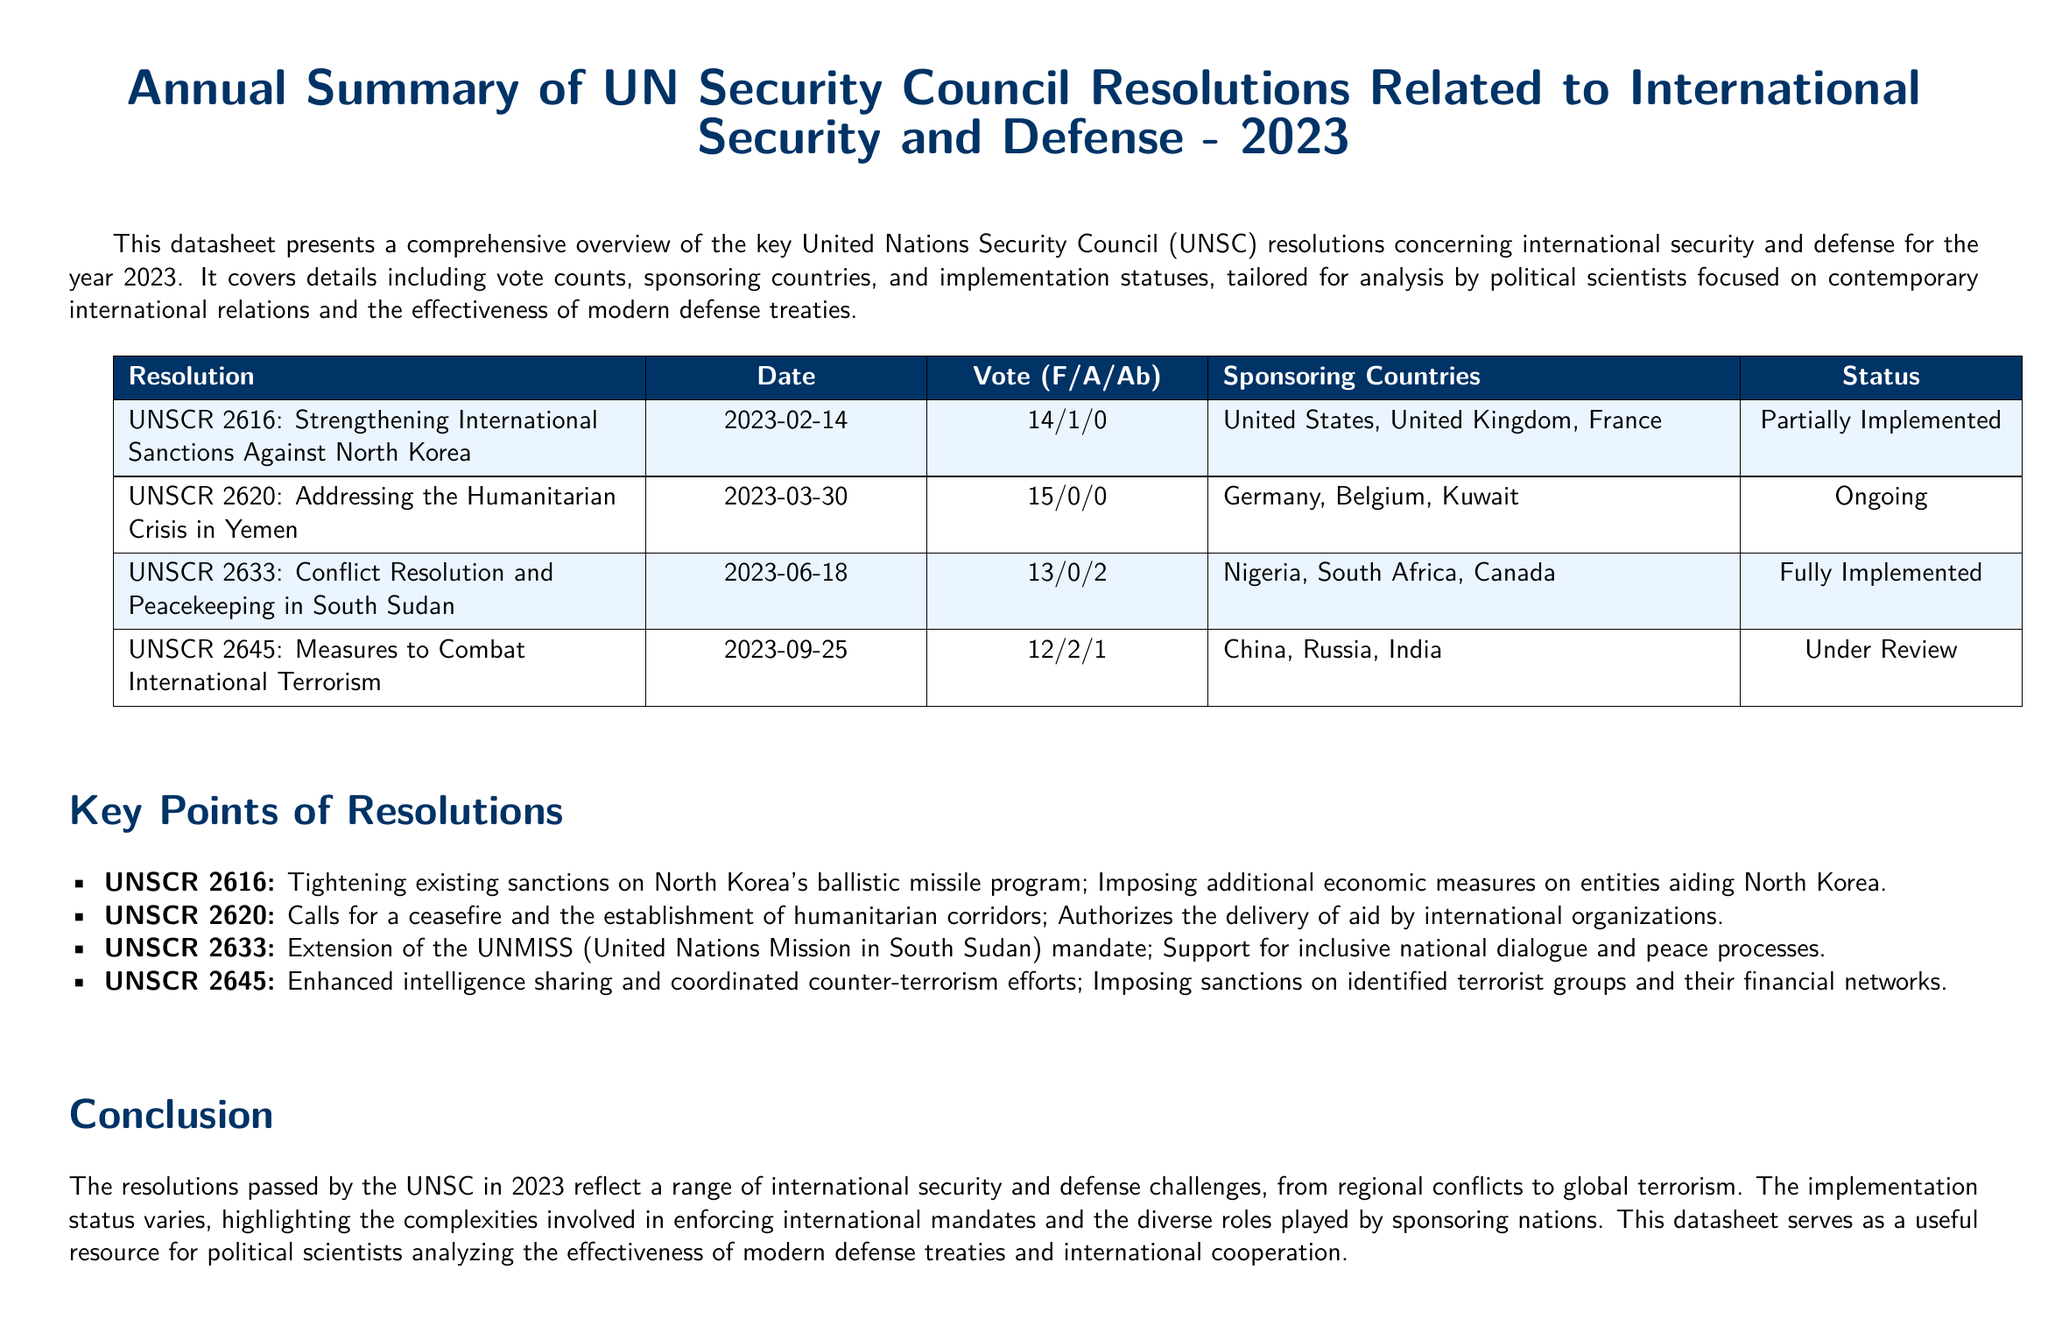What is the date of UNSCR 2616? The date of UNSCR 2616 is specified in the document.
Answer: 2023-02-14 How many countries sponsored UNSCR 2620? The document lists the sponsoring countries for each resolution.
Answer: 3 What is the vote count for UNSCR 2645? The vote count is presented in the format of For, Against, and Abstentions in the document.
Answer: 12/2/1 What is the status of UNSCR 2633? The implementation status of each resolution is provided in the table.
Answer: Fully Implemented Which countries sponsored UNSCR 2645? The document lists the sponsoring countries for each resolution.
Answer: China, Russia, India How many resolutions are categorized as "Ongoing"? The number of resolutions labeled as "Ongoing" can be derived from the implementation statuses detailed in the document.
Answer: 1 Which resolution addresses the humanitarian crisis in Yemen? The document provides titles of resolutions along with their focus areas.
Answer: UNSCR 2620 What implementation status is given to UNSCR 2645? The implementation status is explicitly stated in the document for each resolution.
Answer: Under Review What key point is associated with UNSCR 2616? Key points for each resolution are summarized at the end of the table.
Answer: Tightening existing sanctions on North Korea's ballistic missile program 